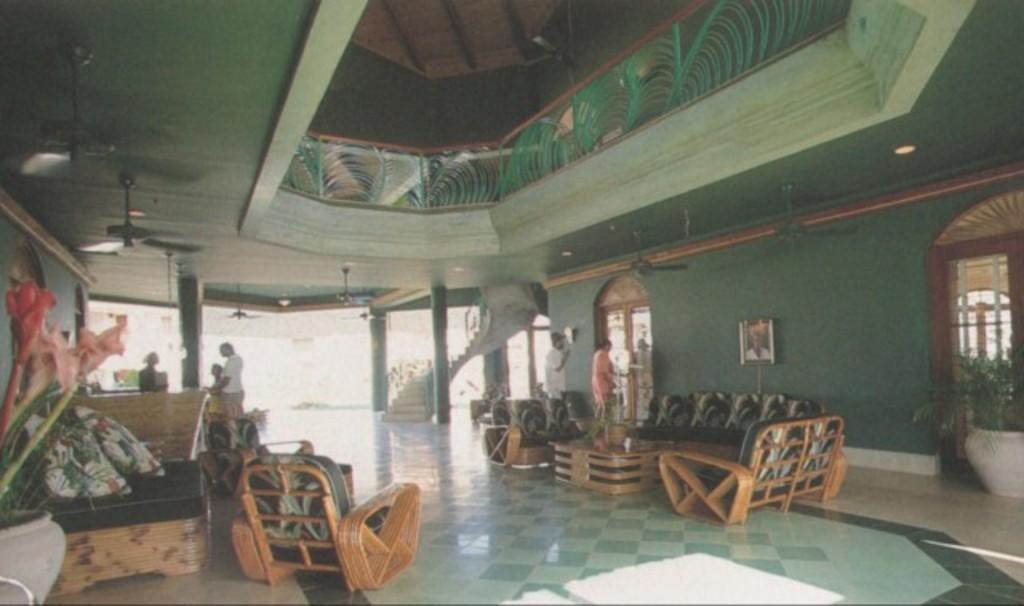In one or two sentences, can you explain what this image depicts? In this image on the right side there is one couch and one table and on the table there is one flower pot. On the top corner of the right side there are two fans and one light. And on the left side there is one flower pot and one plant and there is one window and on the middle of the image there is one door and there are two persons who is standing. In the middle of the image there are some stairs. On the right side there is one chair and there is one flower pot and plant, there are two pillows and three persons standing and on the right side there are two fans and one light on the top of the left corner there are two fans. On the right side there is one photo frame and on the top of the image there is one fan. 